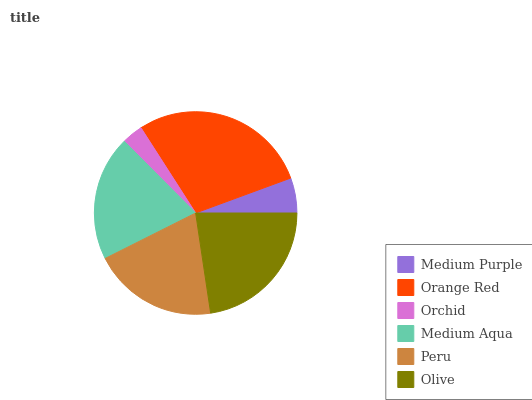Is Orchid the minimum?
Answer yes or no. Yes. Is Orange Red the maximum?
Answer yes or no. Yes. Is Orange Red the minimum?
Answer yes or no. No. Is Orchid the maximum?
Answer yes or no. No. Is Orange Red greater than Orchid?
Answer yes or no. Yes. Is Orchid less than Orange Red?
Answer yes or no. Yes. Is Orchid greater than Orange Red?
Answer yes or no. No. Is Orange Red less than Orchid?
Answer yes or no. No. Is Peru the high median?
Answer yes or no. Yes. Is Medium Aqua the low median?
Answer yes or no. Yes. Is Medium Aqua the high median?
Answer yes or no. No. Is Olive the low median?
Answer yes or no. No. 